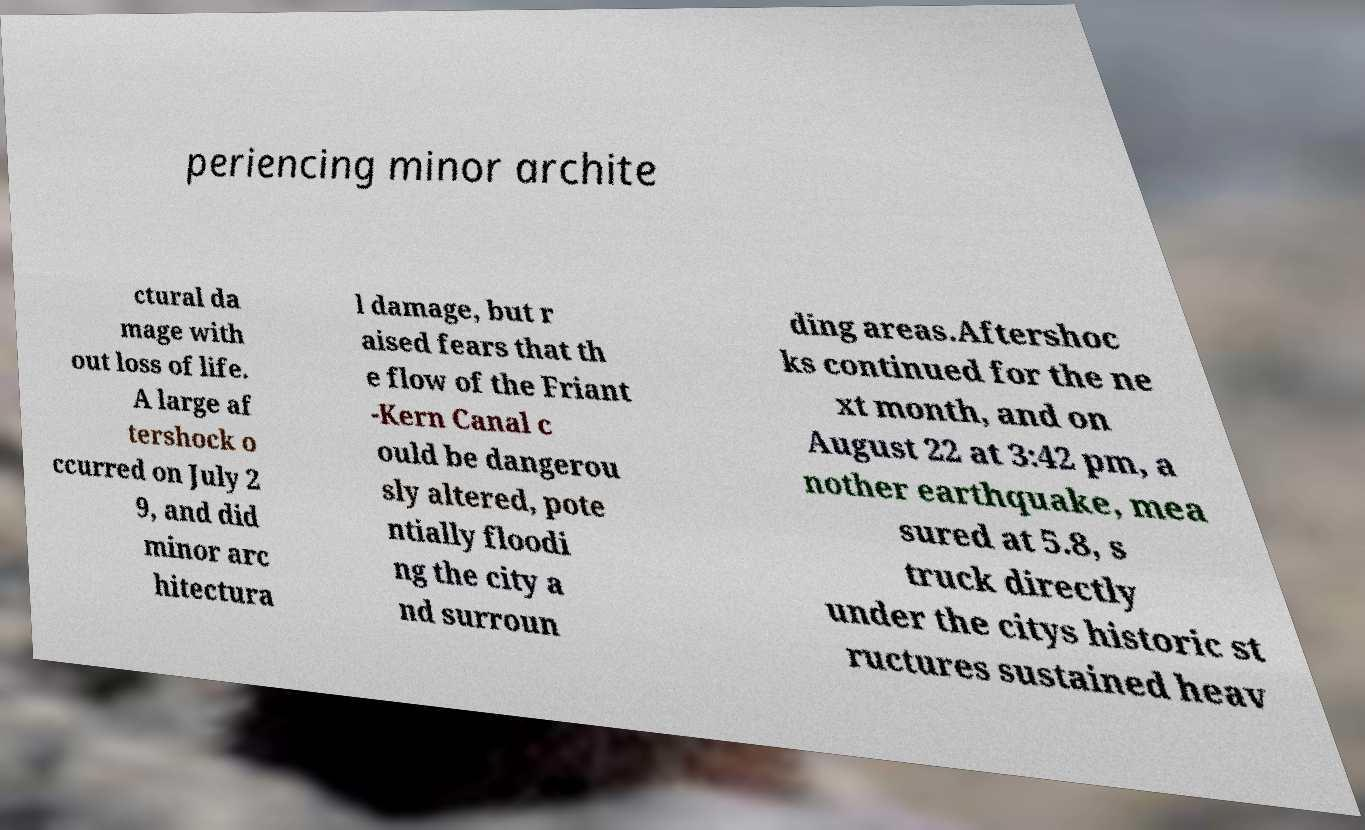I need the written content from this picture converted into text. Can you do that? periencing minor archite ctural da mage with out loss of life. A large af tershock o ccurred on July 2 9, and did minor arc hitectura l damage, but r aised fears that th e flow of the Friant -Kern Canal c ould be dangerou sly altered, pote ntially floodi ng the city a nd surroun ding areas.Aftershoc ks continued for the ne xt month, and on August 22 at 3:42 pm, a nother earthquake, mea sured at 5.8, s truck directly under the citys historic st ructures sustained heav 